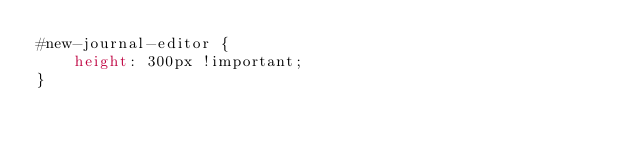Convert code to text. <code><loc_0><loc_0><loc_500><loc_500><_CSS_>#new-journal-editor {
    height: 300px !important;
}</code> 